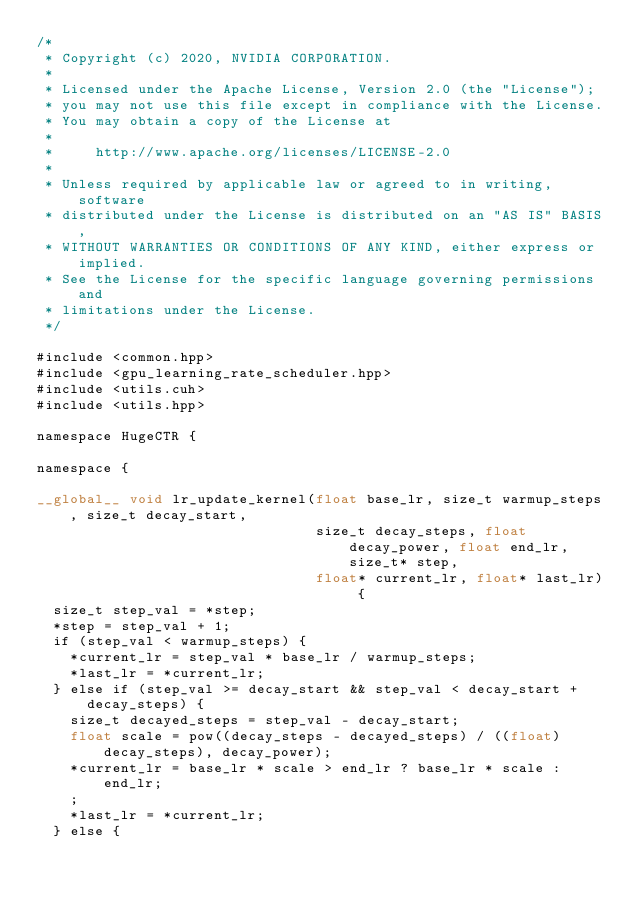<code> <loc_0><loc_0><loc_500><loc_500><_Cuda_>/*
 * Copyright (c) 2020, NVIDIA CORPORATION.
 *
 * Licensed under the Apache License, Version 2.0 (the "License");
 * you may not use this file except in compliance with the License.
 * You may obtain a copy of the License at
 *
 *     http://www.apache.org/licenses/LICENSE-2.0
 *
 * Unless required by applicable law or agreed to in writing, software
 * distributed under the License is distributed on an "AS IS" BASIS,
 * WITHOUT WARRANTIES OR CONDITIONS OF ANY KIND, either express or implied.
 * See the License for the specific language governing permissions and
 * limitations under the License.
 */

#include <common.hpp>
#include <gpu_learning_rate_scheduler.hpp>
#include <utils.cuh>
#include <utils.hpp>

namespace HugeCTR {

namespace {

__global__ void lr_update_kernel(float base_lr, size_t warmup_steps, size_t decay_start,
                                 size_t decay_steps, float decay_power, float end_lr, size_t* step,
                                 float* current_lr, float* last_lr) {
  size_t step_val = *step;
  *step = step_val + 1;
  if (step_val < warmup_steps) {
    *current_lr = step_val * base_lr / warmup_steps;
    *last_lr = *current_lr;
  } else if (step_val >= decay_start && step_val < decay_start + decay_steps) {
    size_t decayed_steps = step_val - decay_start;
    float scale = pow((decay_steps - decayed_steps) / ((float)decay_steps), decay_power);
    *current_lr = base_lr * scale > end_lr ? base_lr * scale : end_lr;
    ;
    *last_lr = *current_lr;
  } else {</code> 